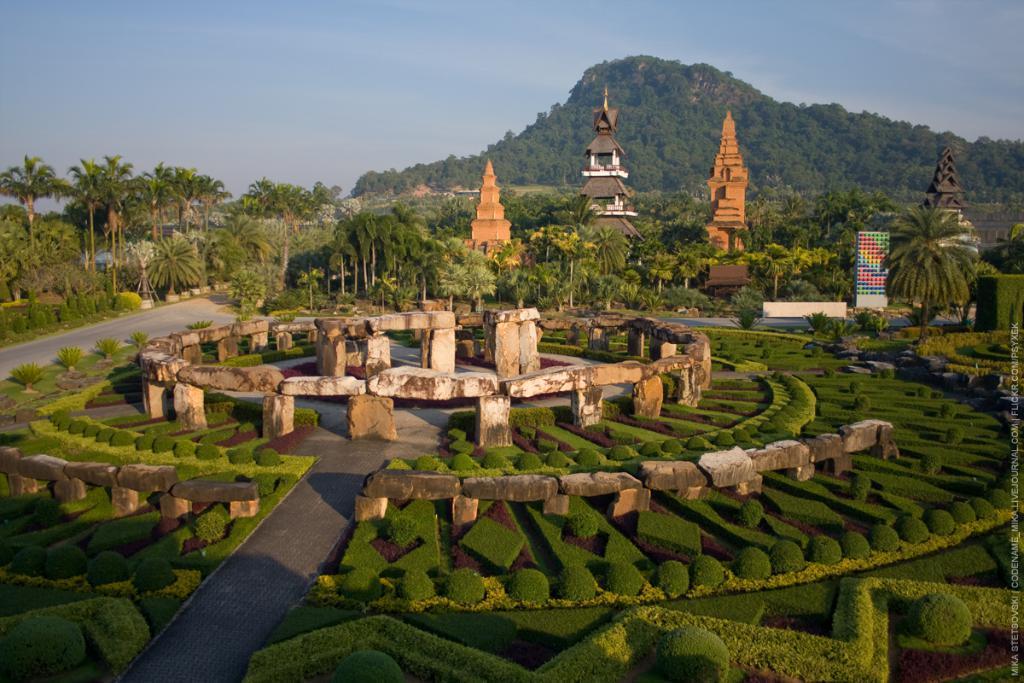In one or two sentences, can you explain what this image depicts? In the foreground of this image, there is a garden with plants and stones. In the background, there are trees, a road, huts, mountains and the sky. 